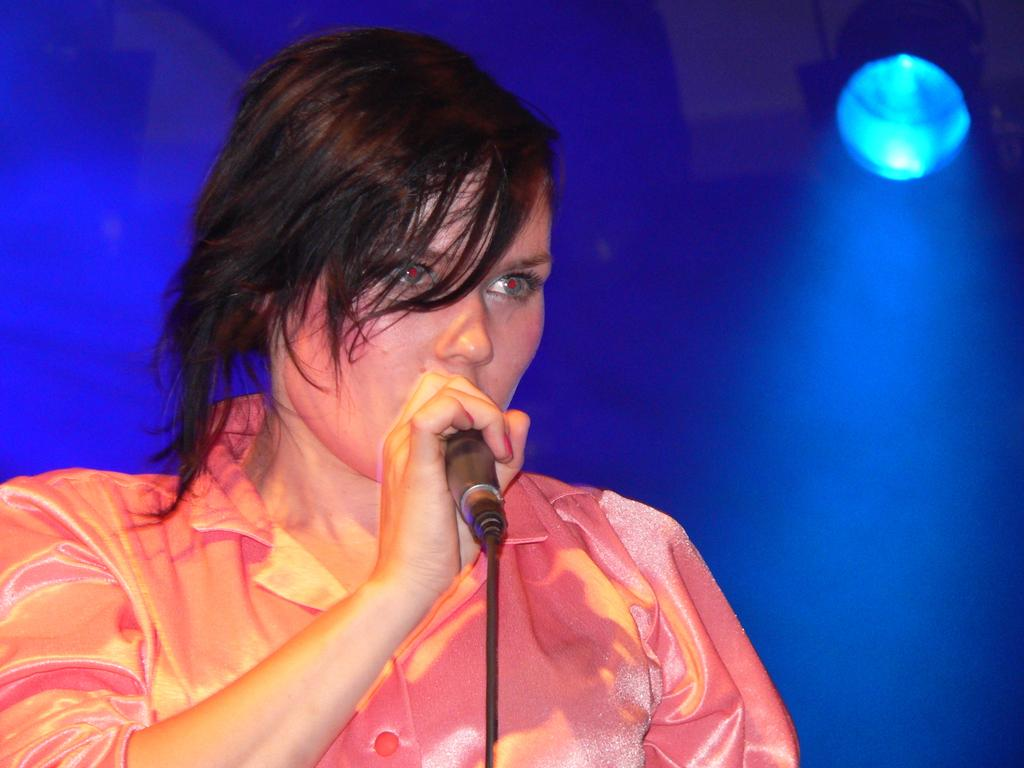What is the main subject of the image? The main subject of the image is a woman. What is the woman holding in the image? The woman is holding a mic. What rhythm is the woman playing in the image? There is no indication of the woman playing any rhythm in the image, as she is only holding a mic. 